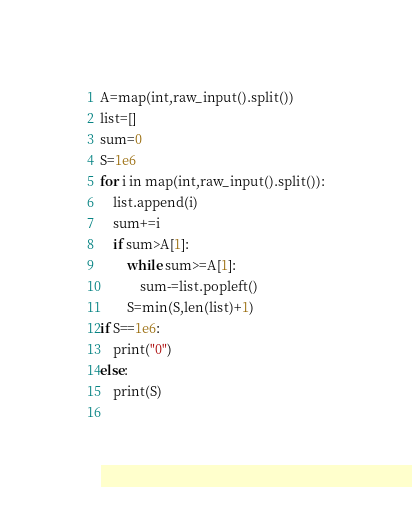Convert code to text. <code><loc_0><loc_0><loc_500><loc_500><_Python_>A=map(int,raw_input().split())
list=[]
sum=0
S=1e6
for i in map(int,raw_input().split()):
    list.append(i)
    sum+=i
    if sum>A[1]:
        while sum>=A[1]:
            sum-=list.popleft()
        S=min(S,len(list)+1)
if S==1e6:
    print("0")
else:
    print(S)
    
</code> 